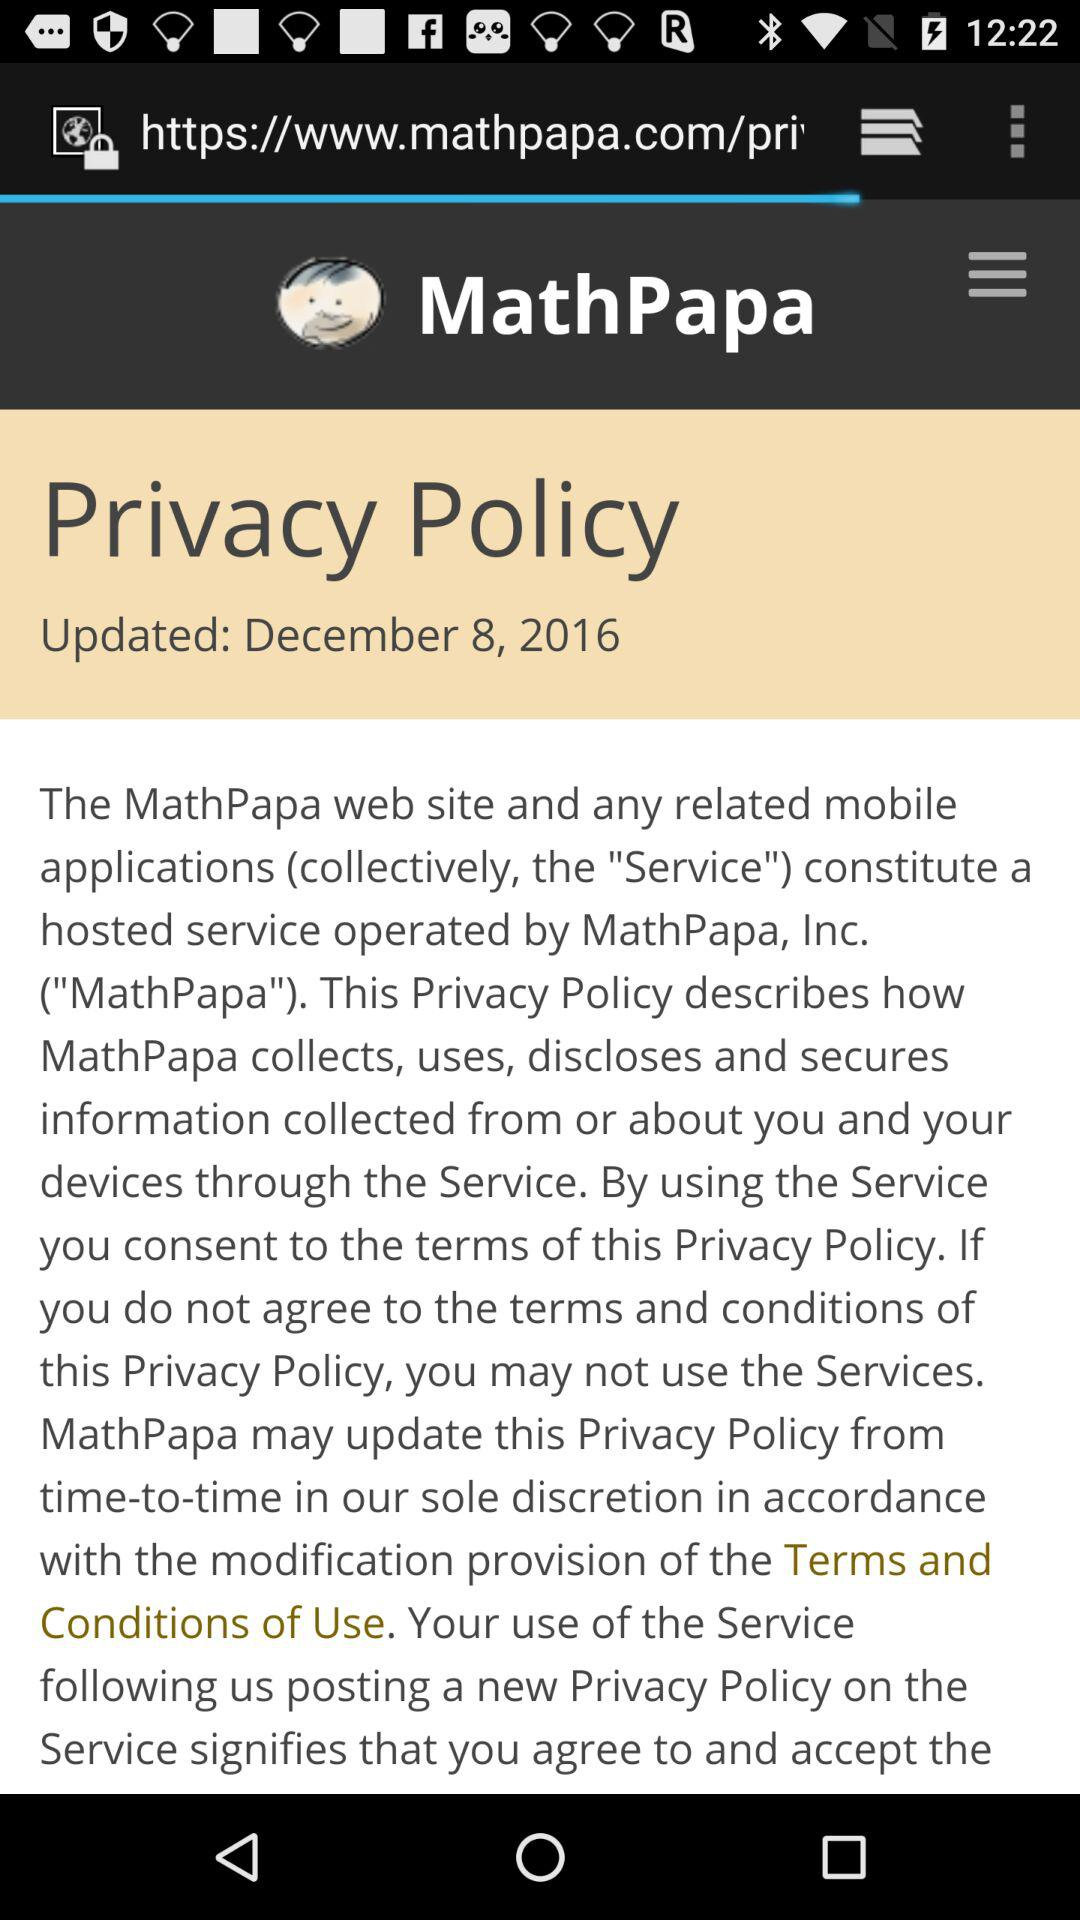When was the Privacy Policy updated? The Privacy Policy was updated on December 8, 2016. 